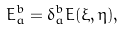Convert formula to latex. <formula><loc_0><loc_0><loc_500><loc_500>E ^ { b } _ { a } = \delta ^ { b } _ { a } E ( \xi , \eta ) ,</formula> 